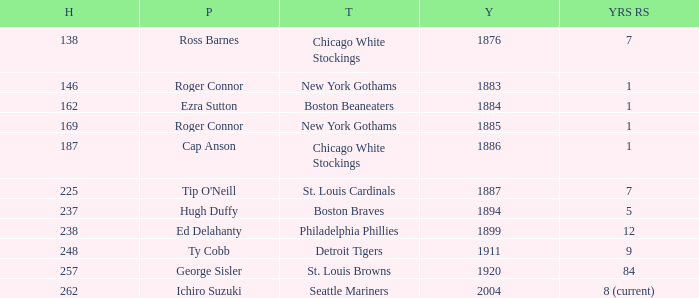Name the hits for years before 1883 138.0. 